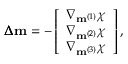<formula> <loc_0><loc_0><loc_500><loc_500>\pm b { \Delta } m = - \left [ \begin{array} { c } { \nabla _ { m ^ { ( 1 ) } } \chi } \\ { \nabla _ { m ^ { ( 2 ) } } \chi } \\ { \nabla _ { m ^ { ( 3 ) } } \chi } \end{array} \right ] ,</formula> 